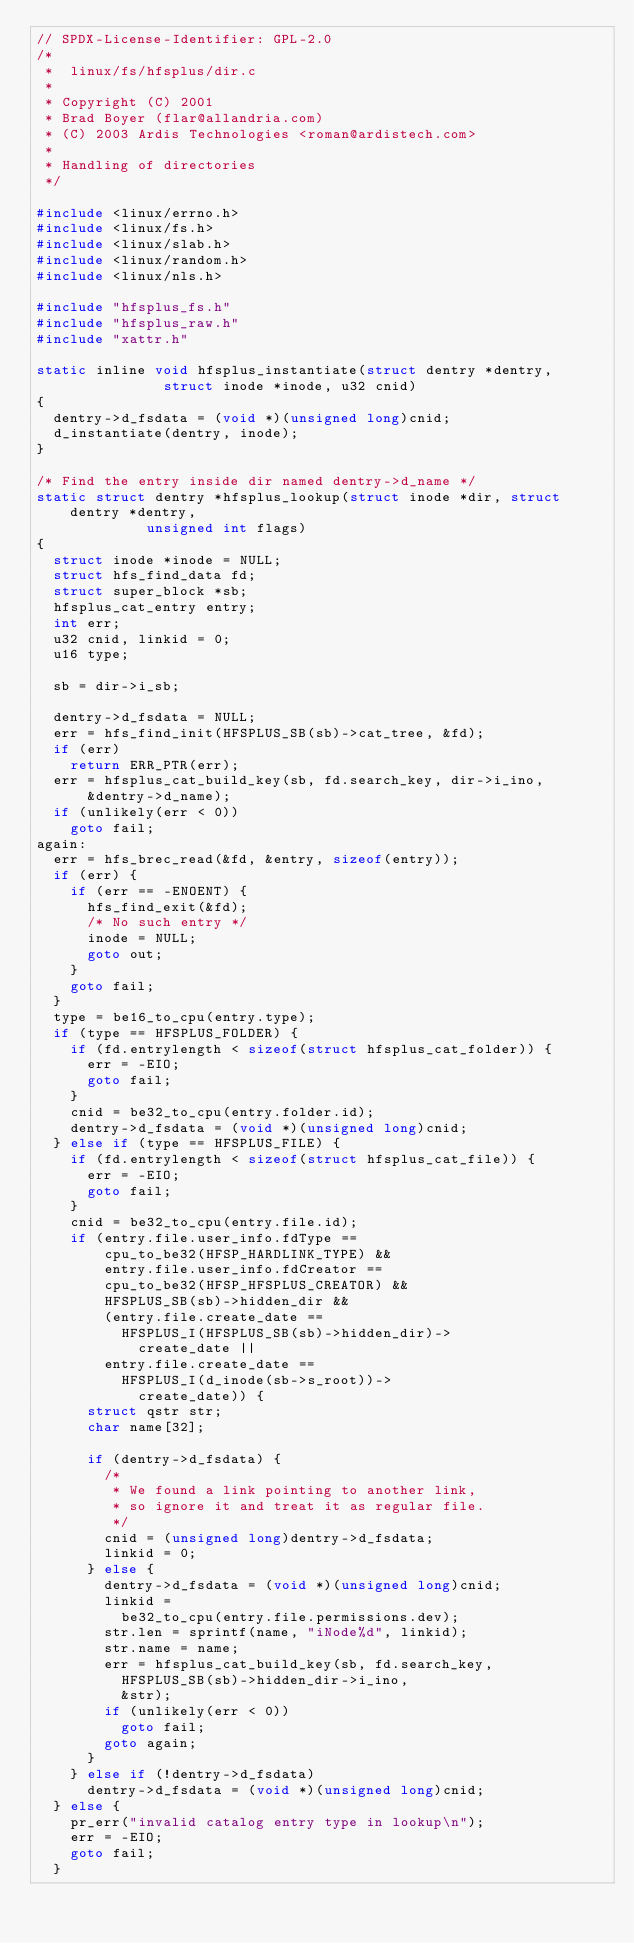Convert code to text. <code><loc_0><loc_0><loc_500><loc_500><_C_>// SPDX-License-Identifier: GPL-2.0
/*
 *  linux/fs/hfsplus/dir.c
 *
 * Copyright (C) 2001
 * Brad Boyer (flar@allandria.com)
 * (C) 2003 Ardis Technologies <roman@ardistech.com>
 *
 * Handling of directories
 */

#include <linux/errno.h>
#include <linux/fs.h>
#include <linux/slab.h>
#include <linux/random.h>
#include <linux/nls.h>

#include "hfsplus_fs.h"
#include "hfsplus_raw.h"
#include "xattr.h"

static inline void hfsplus_instantiate(struct dentry *dentry,
				       struct inode *inode, u32 cnid)
{
	dentry->d_fsdata = (void *)(unsigned long)cnid;
	d_instantiate(dentry, inode);
}

/* Find the entry inside dir named dentry->d_name */
static struct dentry *hfsplus_lookup(struct inode *dir, struct dentry *dentry,
				     unsigned int flags)
{
	struct inode *inode = NULL;
	struct hfs_find_data fd;
	struct super_block *sb;
	hfsplus_cat_entry entry;
	int err;
	u32 cnid, linkid = 0;
	u16 type;

	sb = dir->i_sb;

	dentry->d_fsdata = NULL;
	err = hfs_find_init(HFSPLUS_SB(sb)->cat_tree, &fd);
	if (err)
		return ERR_PTR(err);
	err = hfsplus_cat_build_key(sb, fd.search_key, dir->i_ino,
			&dentry->d_name);
	if (unlikely(err < 0))
		goto fail;
again:
	err = hfs_brec_read(&fd, &entry, sizeof(entry));
	if (err) {
		if (err == -ENOENT) {
			hfs_find_exit(&fd);
			/* No such entry */
			inode = NULL;
			goto out;
		}
		goto fail;
	}
	type = be16_to_cpu(entry.type);
	if (type == HFSPLUS_FOLDER) {
		if (fd.entrylength < sizeof(struct hfsplus_cat_folder)) {
			err = -EIO;
			goto fail;
		}
		cnid = be32_to_cpu(entry.folder.id);
		dentry->d_fsdata = (void *)(unsigned long)cnid;
	} else if (type == HFSPLUS_FILE) {
		if (fd.entrylength < sizeof(struct hfsplus_cat_file)) {
			err = -EIO;
			goto fail;
		}
		cnid = be32_to_cpu(entry.file.id);
		if (entry.file.user_info.fdType ==
				cpu_to_be32(HFSP_HARDLINK_TYPE) &&
				entry.file.user_info.fdCreator ==
				cpu_to_be32(HFSP_HFSPLUS_CREATOR) &&
				HFSPLUS_SB(sb)->hidden_dir &&
				(entry.file.create_date ==
					HFSPLUS_I(HFSPLUS_SB(sb)->hidden_dir)->
						create_date ||
				entry.file.create_date ==
					HFSPLUS_I(d_inode(sb->s_root))->
						create_date)) {
			struct qstr str;
			char name[32];

			if (dentry->d_fsdata) {
				/*
				 * We found a link pointing to another link,
				 * so ignore it and treat it as regular file.
				 */
				cnid = (unsigned long)dentry->d_fsdata;
				linkid = 0;
			} else {
				dentry->d_fsdata = (void *)(unsigned long)cnid;
				linkid =
					be32_to_cpu(entry.file.permissions.dev);
				str.len = sprintf(name, "iNode%d", linkid);
				str.name = name;
				err = hfsplus_cat_build_key(sb, fd.search_key,
					HFSPLUS_SB(sb)->hidden_dir->i_ino,
					&str);
				if (unlikely(err < 0))
					goto fail;
				goto again;
			}
		} else if (!dentry->d_fsdata)
			dentry->d_fsdata = (void *)(unsigned long)cnid;
	} else {
		pr_err("invalid catalog entry type in lookup\n");
		err = -EIO;
		goto fail;
	}</code> 